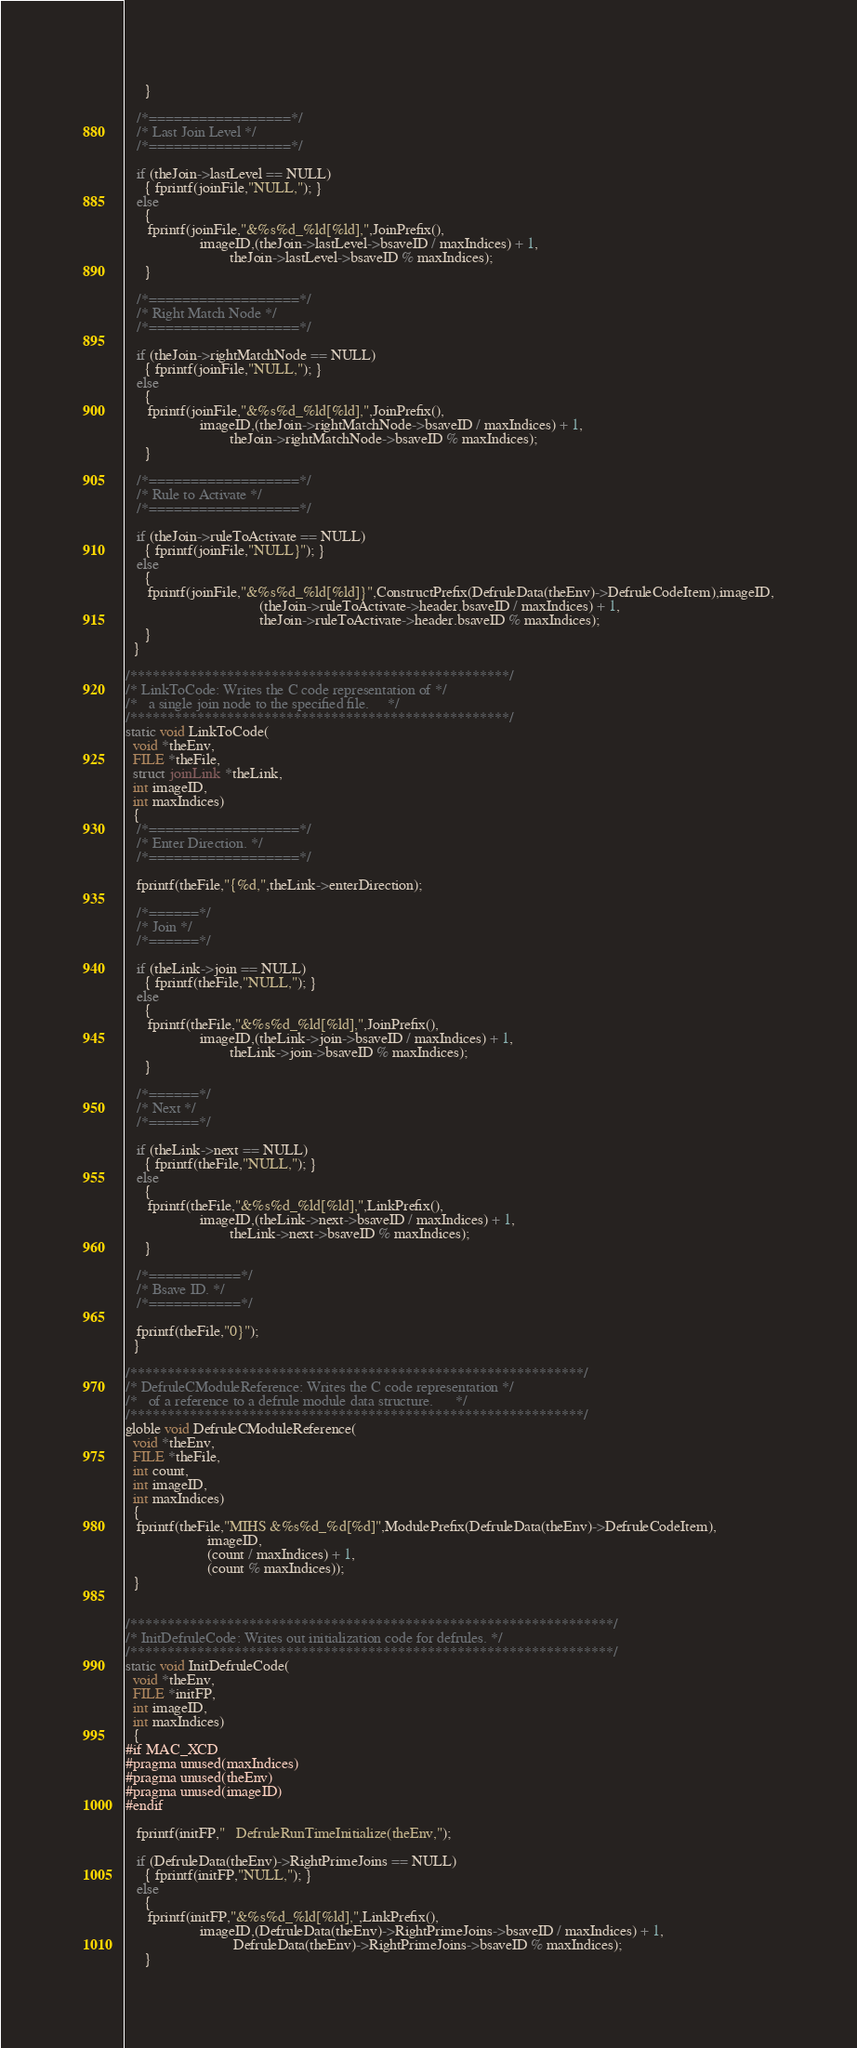<code> <loc_0><loc_0><loc_500><loc_500><_C_>     }

   /*=================*/
   /* Last Join Level */
   /*=================*/

   if (theJoin->lastLevel == NULL)
     { fprintf(joinFile,"NULL,"); }
   else
     {
      fprintf(joinFile,"&%s%d_%ld[%ld],",JoinPrefix(),
                    imageID,(theJoin->lastLevel->bsaveID / maxIndices) + 1,
                            theJoin->lastLevel->bsaveID % maxIndices);
     }

   /*==================*/
   /* Right Match Node */
   /*==================*/

   if (theJoin->rightMatchNode == NULL)
     { fprintf(joinFile,"NULL,"); }
   else
     {
      fprintf(joinFile,"&%s%d_%ld[%ld],",JoinPrefix(),
                    imageID,(theJoin->rightMatchNode->bsaveID / maxIndices) + 1,
                            theJoin->rightMatchNode->bsaveID % maxIndices);
     }

   /*==================*/
   /* Rule to Activate */
   /*==================*/

   if (theJoin->ruleToActivate == NULL)
     { fprintf(joinFile,"NULL}"); }
   else
     {
      fprintf(joinFile,"&%s%d_%ld[%ld]}",ConstructPrefix(DefruleData(theEnv)->DefruleCodeItem),imageID,
                                    (theJoin->ruleToActivate->header.bsaveID / maxIndices) + 1,
                                    theJoin->ruleToActivate->header.bsaveID % maxIndices);
     }
  }

/***************************************************/
/* LinkToCode: Writes the C code representation of */
/*   a single join node to the specified file.     */
/***************************************************/
static void LinkToCode(
  void *theEnv,
  FILE *theFile,
  struct joinLink *theLink,
  int imageID,
  int maxIndices)
  {    
   /*==================*/
   /* Enter Direction. */
   /*==================*/

   fprintf(theFile,"{%d,",theLink->enterDirection);

   /*======*/
   /* Join */
   /*======*/

   if (theLink->join == NULL)
     { fprintf(theFile,"NULL,"); }
   else
     {
      fprintf(theFile,"&%s%d_%ld[%ld],",JoinPrefix(),
                    imageID,(theLink->join->bsaveID / maxIndices) + 1,
                            theLink->join->bsaveID % maxIndices);
     }

   /*======*/
   /* Next */
   /*======*/

   if (theLink->next == NULL)
     { fprintf(theFile,"NULL,"); }
   else
     {
      fprintf(theFile,"&%s%d_%ld[%ld],",LinkPrefix(),
                    imageID,(theLink->next->bsaveID / maxIndices) + 1,
                            theLink->next->bsaveID % maxIndices);
     }
     
   /*===========*/
   /* Bsave ID. */
   /*===========*/

   fprintf(theFile,"0}");
  }

/*************************************************************/
/* DefruleCModuleReference: Writes the C code representation */
/*   of a reference to a defrule module data structure.      */
/*************************************************************/
globle void DefruleCModuleReference(
  void *theEnv,
  FILE *theFile,
  int count,
  int imageID,
  int maxIndices)
  {
   fprintf(theFile,"MIHS &%s%d_%d[%d]",ModulePrefix(DefruleData(theEnv)->DefruleCodeItem),
                      imageID,
                      (count / maxIndices) + 1,
                      (count % maxIndices));
  }


/*****************************************************************/
/* InitDefruleCode: Writes out initialization code for defrules. */
/*****************************************************************/
static void InitDefruleCode(
  void *theEnv,
  FILE *initFP,
  int imageID,
  int maxIndices)
  {
#if MAC_XCD
#pragma unused(maxIndices)
#pragma unused(theEnv)
#pragma unused(imageID)
#endif

   fprintf(initFP,"   DefruleRunTimeInitialize(theEnv,");

   if (DefruleData(theEnv)->RightPrimeJoins == NULL)
     { fprintf(initFP,"NULL,"); }
   else
     {
      fprintf(initFP,"&%s%d_%ld[%ld],",LinkPrefix(),
                    imageID,(DefruleData(theEnv)->RightPrimeJoins->bsaveID / maxIndices) + 1,
                             DefruleData(theEnv)->RightPrimeJoins->bsaveID % maxIndices);
     }
</code> 